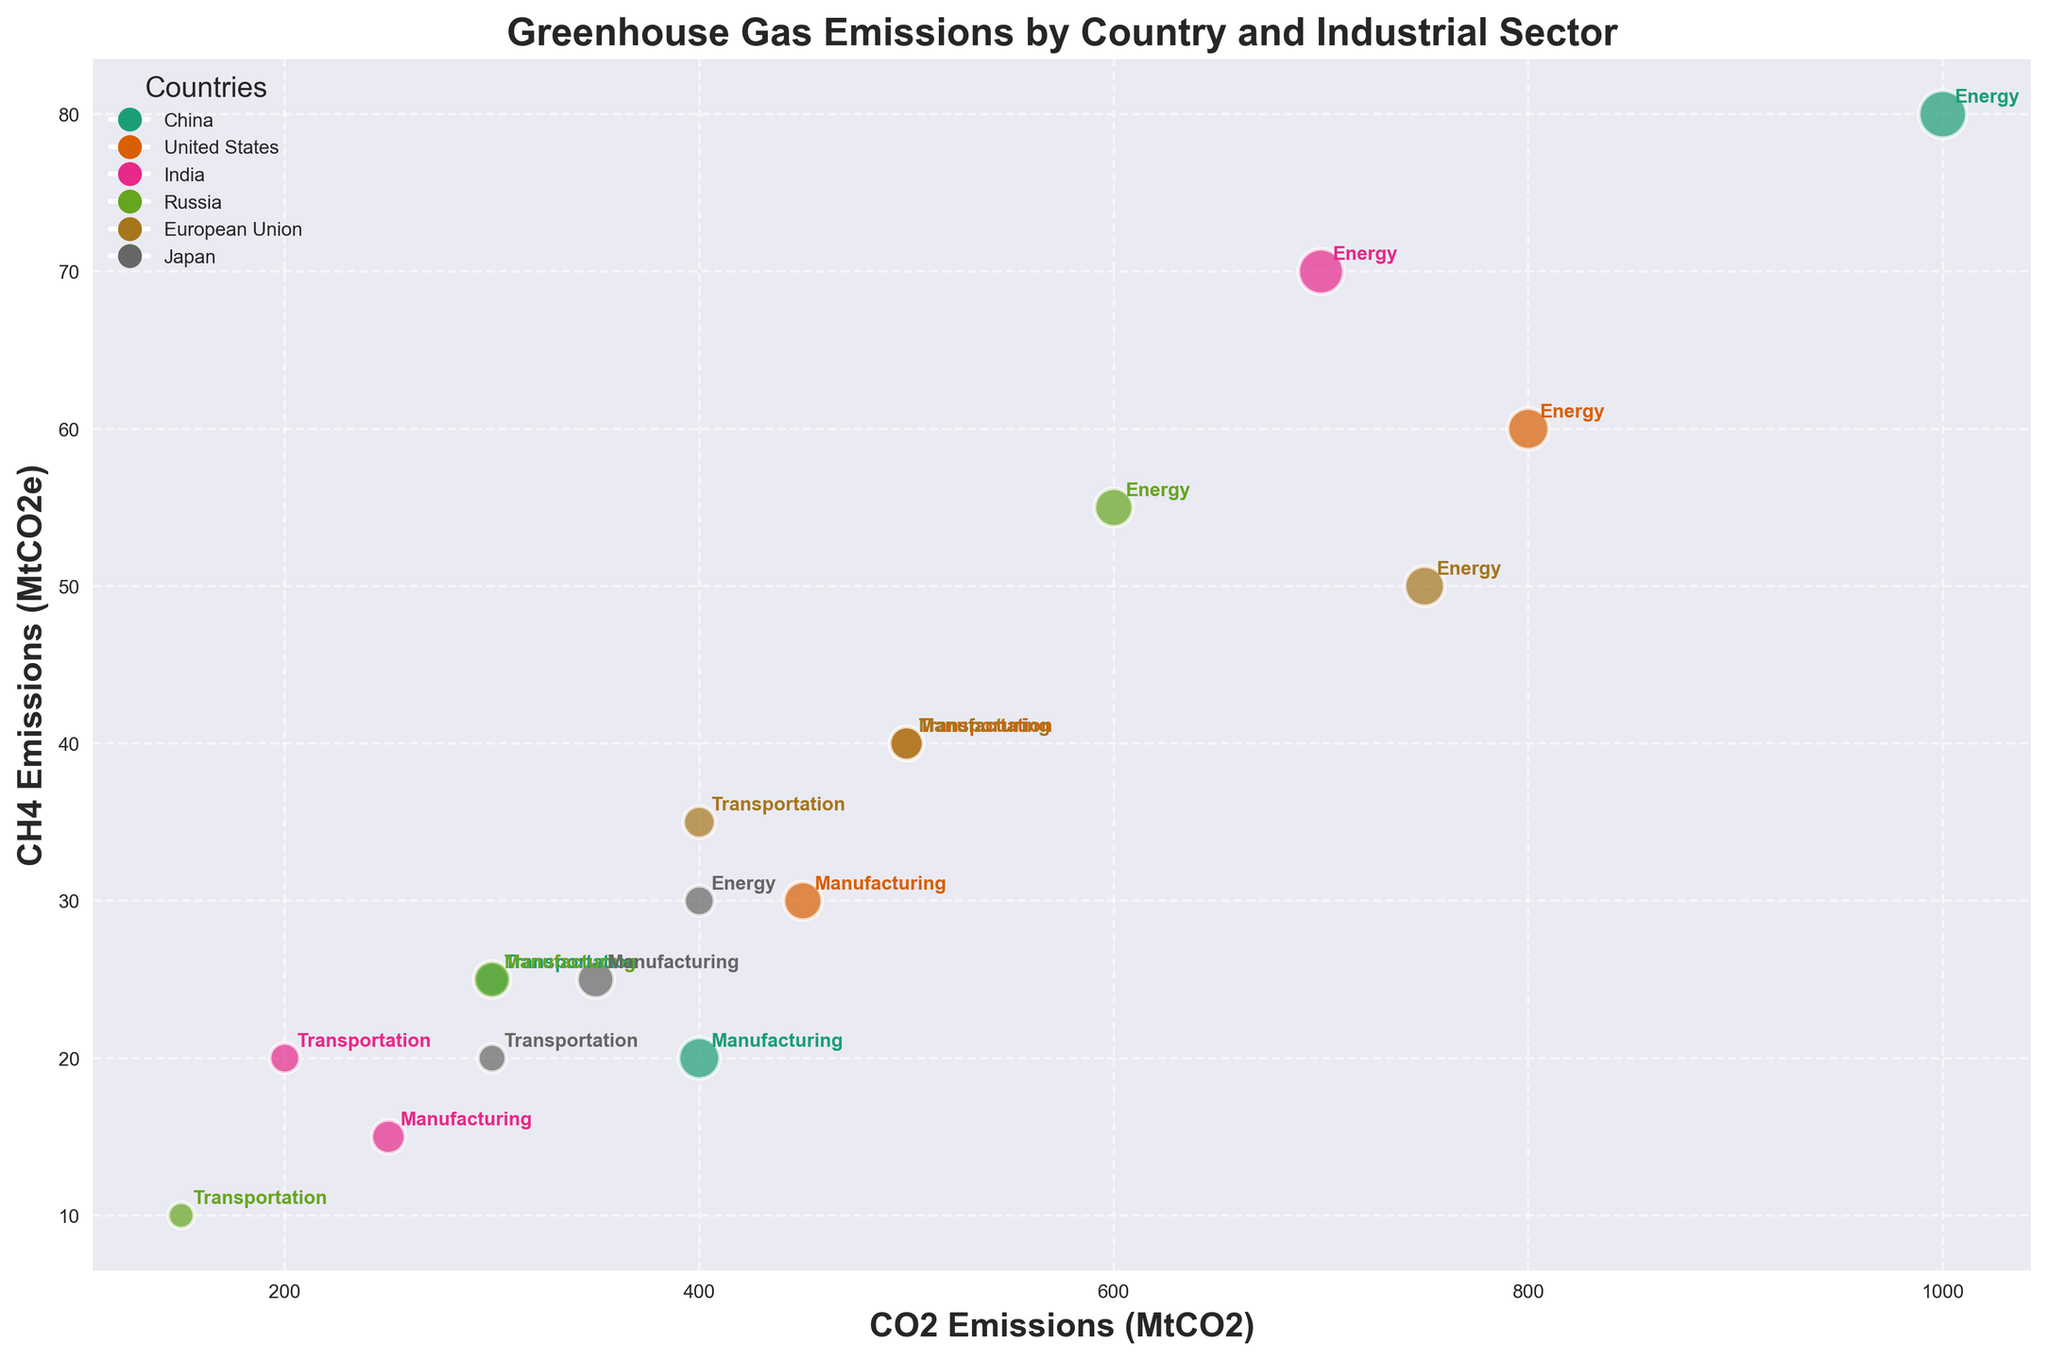What is the title of the figure? The title of the figure is displayed at the top in bold font. It reads "Greenhouse Gas Emissions by Country and Industrial Sector".
Answer: Greenhouse Gas Emissions by Country and Industrial Sector What are the labeled axes in the figure? The x-axis represents "CO2 Emissions (MtCO2)", and the y-axis represents "CH4 Emissions (MtCO2e)".
Answer: CO2 Emissions (MtCO2) and CH4 Emissions (MtCO2e) Which country has the highest CO2 emissions in the energy sector? By looking at the x-axis values and identifying the color and labels of the bubbles, China has the highest CO2 emissions in the energy sector.
Answer: China How do the CH4 emissions from transportation in Japan compare to those in the United States? The size and position of the bubbles representing transportation for Japan and the United States show that the United States has higher CH4 emissions in transportation than Japan.
Answer: Higher Which sector in the European Union has the largest difference in CH4 emissions compared to the energy sector? By comparing the positions of the bubbles for the European Union sectors, transportation has a CH4 emission of 35 MtCO2e, and manufacturing has 40 MtCO2e, which compares to the energy sector's 50 MtCO2e. The transportation sector has the largest difference of 15 MtCO2e.
Answer: Transportation What is the bubble size indicator in the chart? The size of the bubbles represents the N2O emissions, scaled up by a factor of 20 for visual effect.
Answer: N2O emissions Which country has the smallest CH4 emissions in manufacturing? By identifying the smallest y-axis position among the bubbles labeled for manufacturing, Japan has the smallest CH4 emissions in manufacturing.
Answer: Japan How do the total CO2 emissions from the energy sectors of China and the United States compare? China's energy CO2 emissions are 1000 MtCO2, and the United States is 800 MtCO2. China has 200 MtCO2 more emissions than the United States.
Answer: China emits 200 MtCO2 more Which industrial sector in Russia has the largest bubble size? By comparing the sizes of the bubbles within Russia's sectors, the manufacturing sector has the largest bubble size, indicating the highest N2O emissions.
Answer: Manufacturing What trend is noticeable in the relationship between CO2 and CH4 emissions among most countries? Generally, higher CO2 emissions correspond to higher CH4 emissions, as seen from the positively sloping clusters of bubbles for each country.
Answer: Positive correlation 